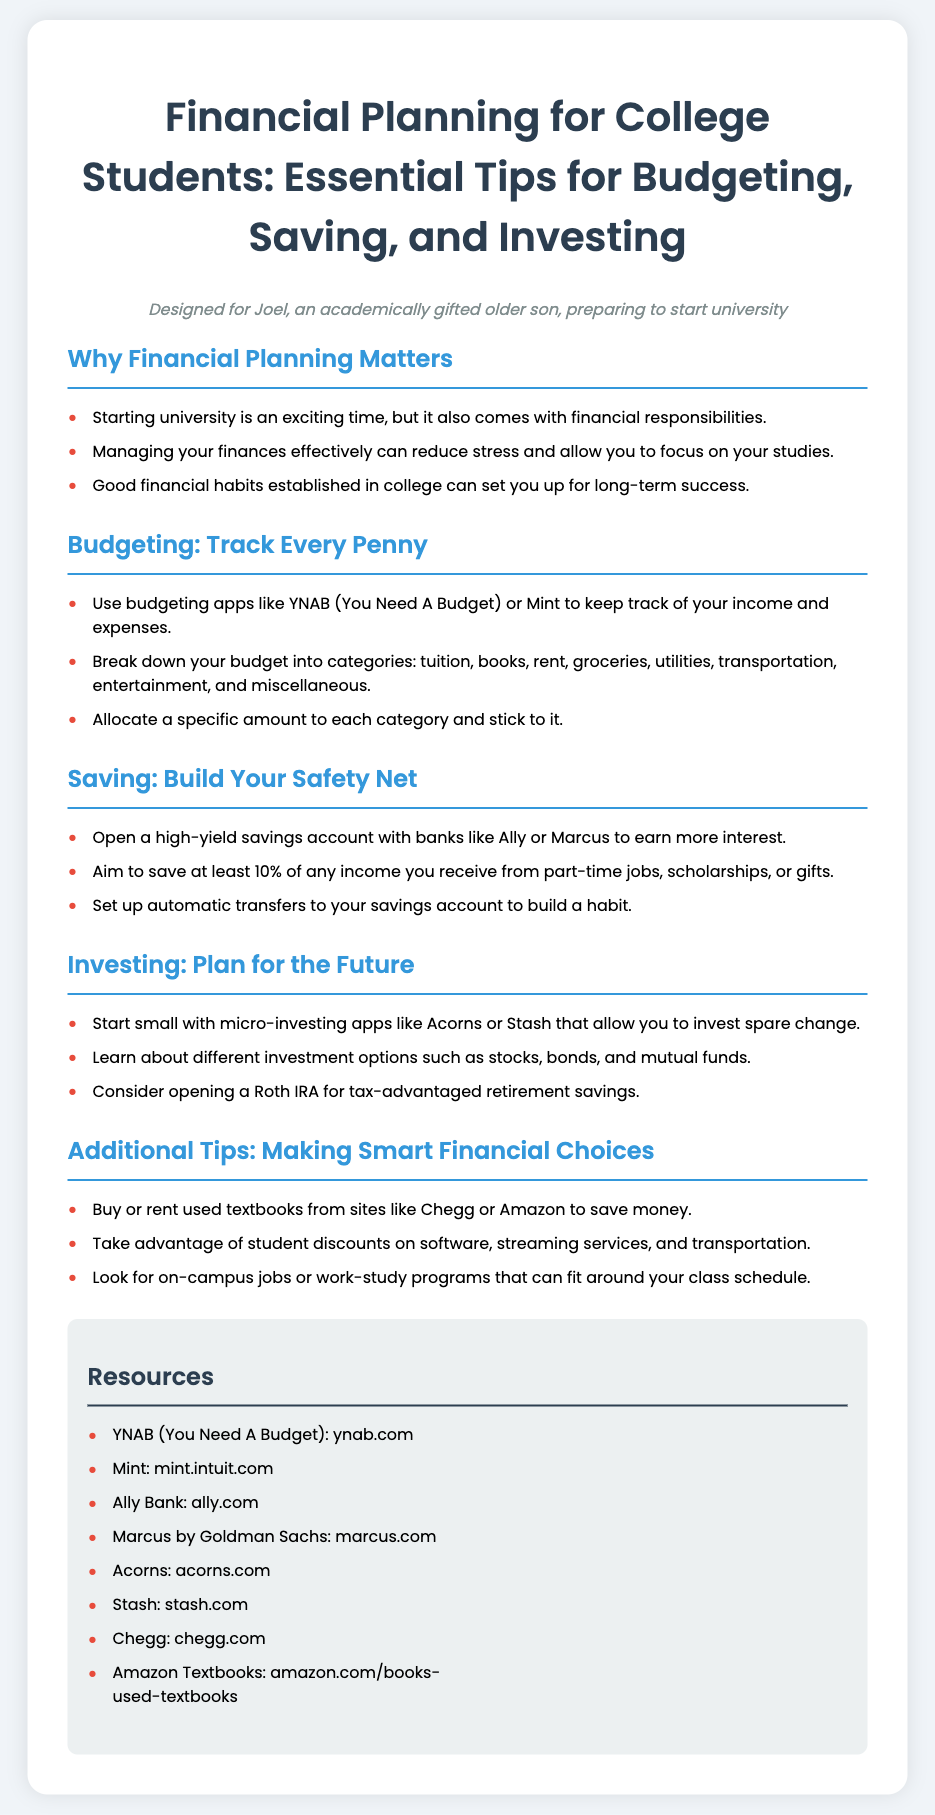What is the title of the poster? The title of the poster is located at the top of the document.
Answer: Financial Planning for College Students: Essential Tips for Budgeting, Saving, and Investing What is a recommended budgeting app mentioned? The document lists budgeting apps in the budgeting section.
Answer: YNAB (You Need A Budget) What percentage should you aim to save from your income? The saving section specifies the target savings percentage.
Answer: 10% Which investment account is suggested for tax-advantaged savings? The investing section mentions a specific type of account for retirement savings.
Answer: Roth IRA What is one source for buying used textbooks? The additional tips section provides a specific source for textbooks.
Answer: Chegg How many sections are there in the poster? Count the section headings to determine the total number.
Answer: Five What background color is used for the resources section? The document describes the color used in the resources section.
Answer: Light gray (ecf0f1) What activity can help you make smart financial choices related to employment? The additional tips section mentions a type of job option for students.
Answer: On-campus jobs 